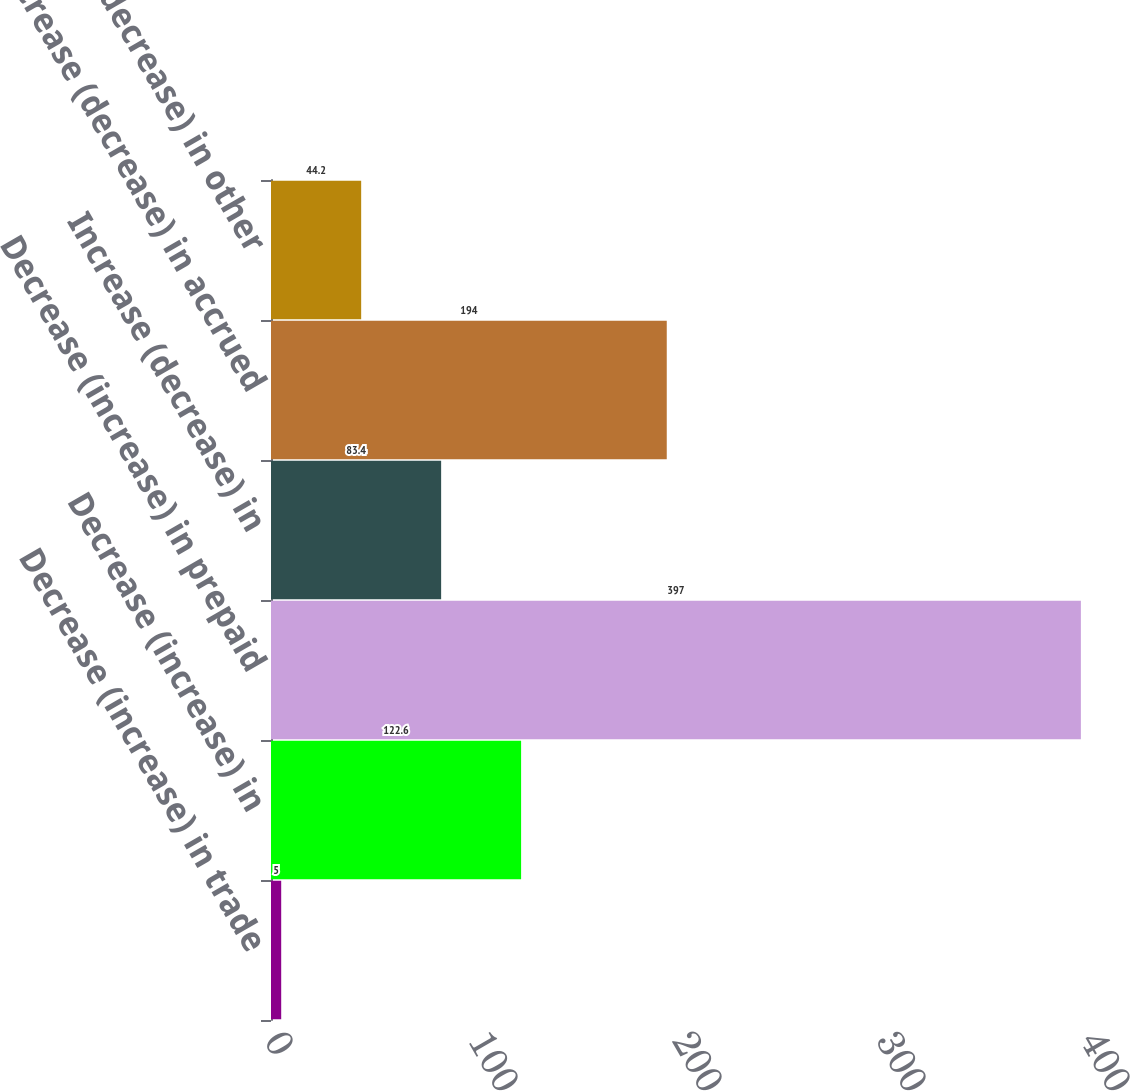<chart> <loc_0><loc_0><loc_500><loc_500><bar_chart><fcel>Decrease (increase) in trade<fcel>Decrease (increase) in<fcel>Decrease (increase) in prepaid<fcel>Increase (decrease) in<fcel>Increase (decrease) in accrued<fcel>Increase (decrease) in other<nl><fcel>5<fcel>122.6<fcel>397<fcel>83.4<fcel>194<fcel>44.2<nl></chart> 